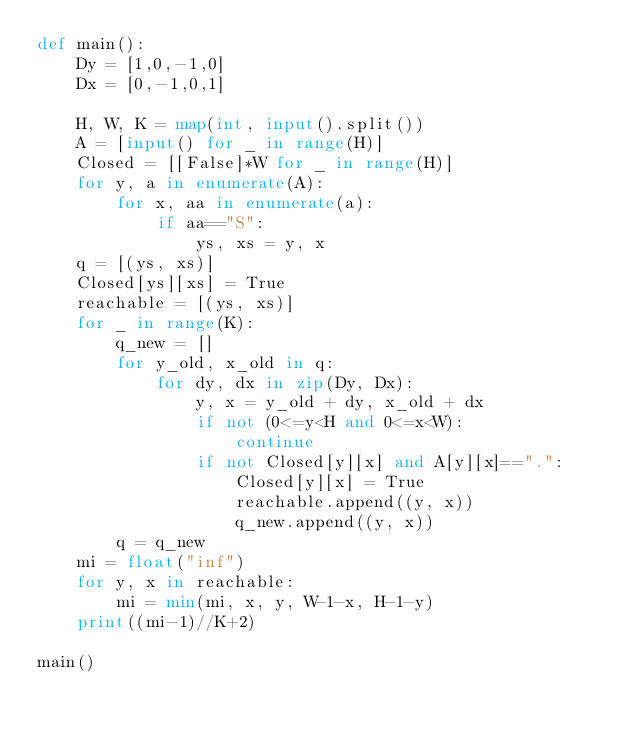<code> <loc_0><loc_0><loc_500><loc_500><_Python_>def main():
    Dy = [1,0,-1,0]
    Dx = [0,-1,0,1]
    
    H, W, K = map(int, input().split())
    A = [input() for _ in range(H)]
    Closed = [[False]*W for _ in range(H)]
    for y, a in enumerate(A):
        for x, aa in enumerate(a):
            if aa=="S":
                ys, xs = y, x
    q = [(ys, xs)]
    Closed[ys][xs] = True
    reachable = [(ys, xs)]
    for _ in range(K):
        q_new = []
        for y_old, x_old in q:
            for dy, dx in zip(Dy, Dx):
                y, x = y_old + dy, x_old + dx
                if not (0<=y<H and 0<=x<W):
                    continue
                if not Closed[y][x] and A[y][x]==".":
                    Closed[y][x] = True
                    reachable.append((y, x))
                    q_new.append((y, x))
        q = q_new
    mi = float("inf")
    for y, x in reachable:
        mi = min(mi, x, y, W-1-x, H-1-y)
    print((mi-1)//K+2)

main()
</code> 